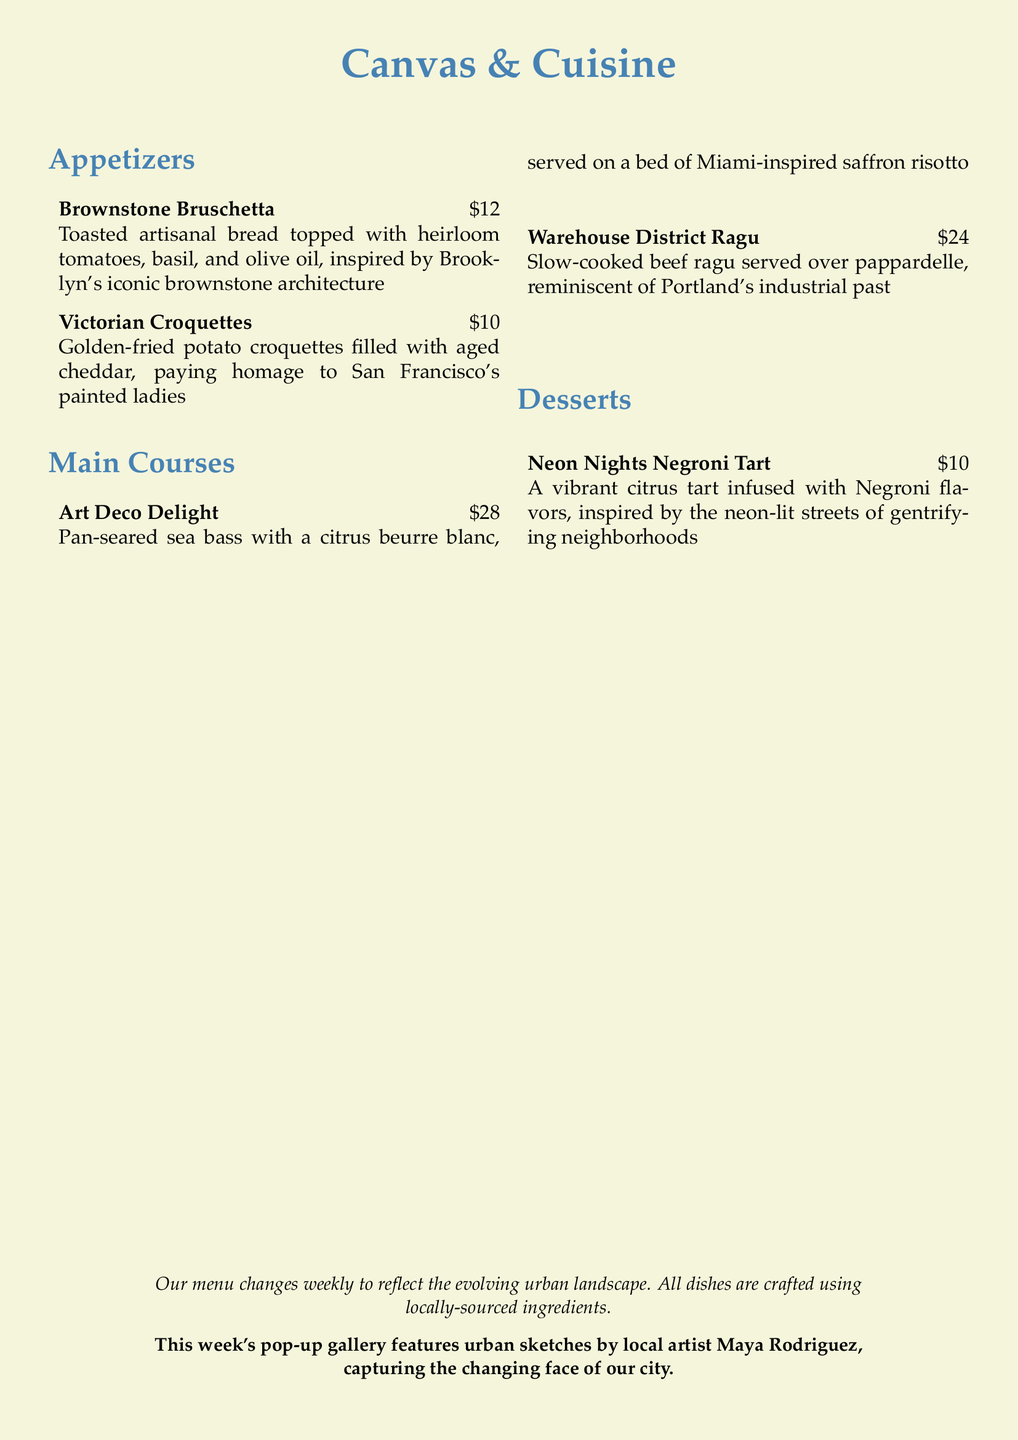What is the name of the pop-up dinner series? The pop-up dinner series is called "Canvas & Cuisine."
Answer: Canvas & Cuisine How many appetizers are featured on the menu? The menu lists a total of 2 appetizers.
Answer: 2 What dish is inspired by Brooklyn's brownstone architecture? The dish inspired by Brooklyn's architecture is "Brownstone Bruschetta."
Answer: Brownstone Bruschetta What is the price of the main course "Warehouse District Ragu"? The price listed for the main course "Warehouse District Ragu" is $24.
Answer: $24 What type of dessert is inspired by neon-lit streets? The dessert inspired by neon-lit streets is "Neon Nights Negroni Tart."
Answer: Neon Nights Negroni Tart Which local artist is featured in this week's pop-up gallery? The featured local artist is Maya Rodriguez.
Answer: Maya Rodriguez What main course is served on a bed of saffron risotto? The main course served on a bed of saffron risotto is "Art Deco Delight."
Answer: Art Deco Delight How often does the menu change? The menu changes weekly.
Answer: Weekly 